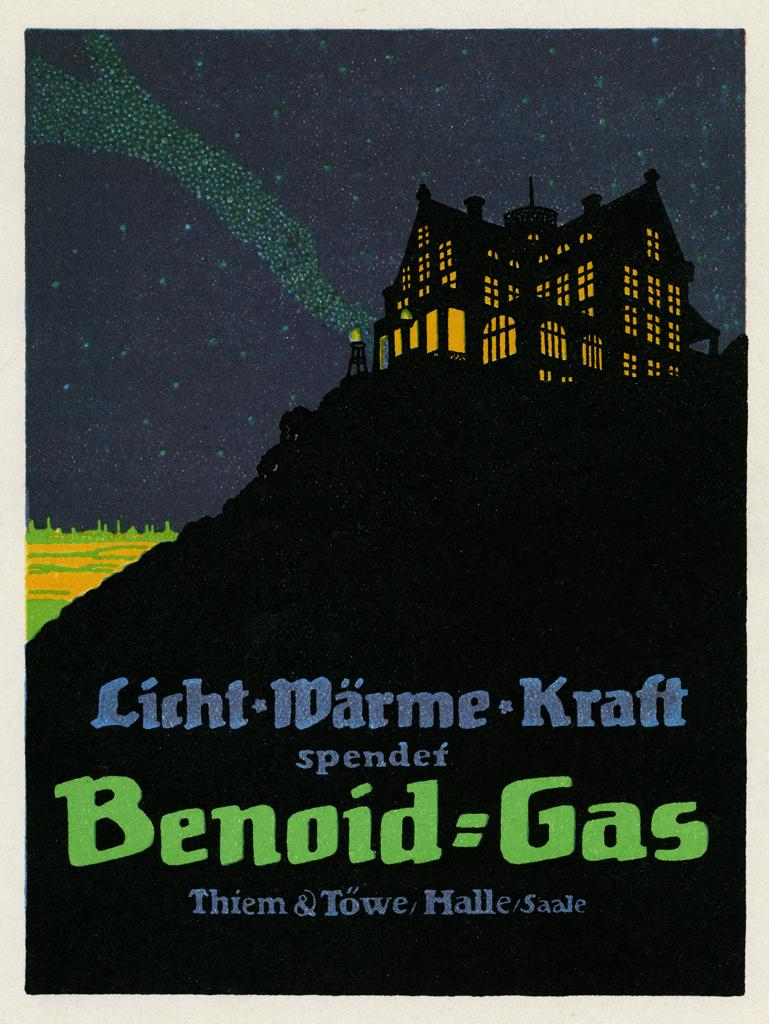<image>
Offer a succinct explanation of the picture presented. a poster with a dark house on a cliff and the words Benoid=Gas 